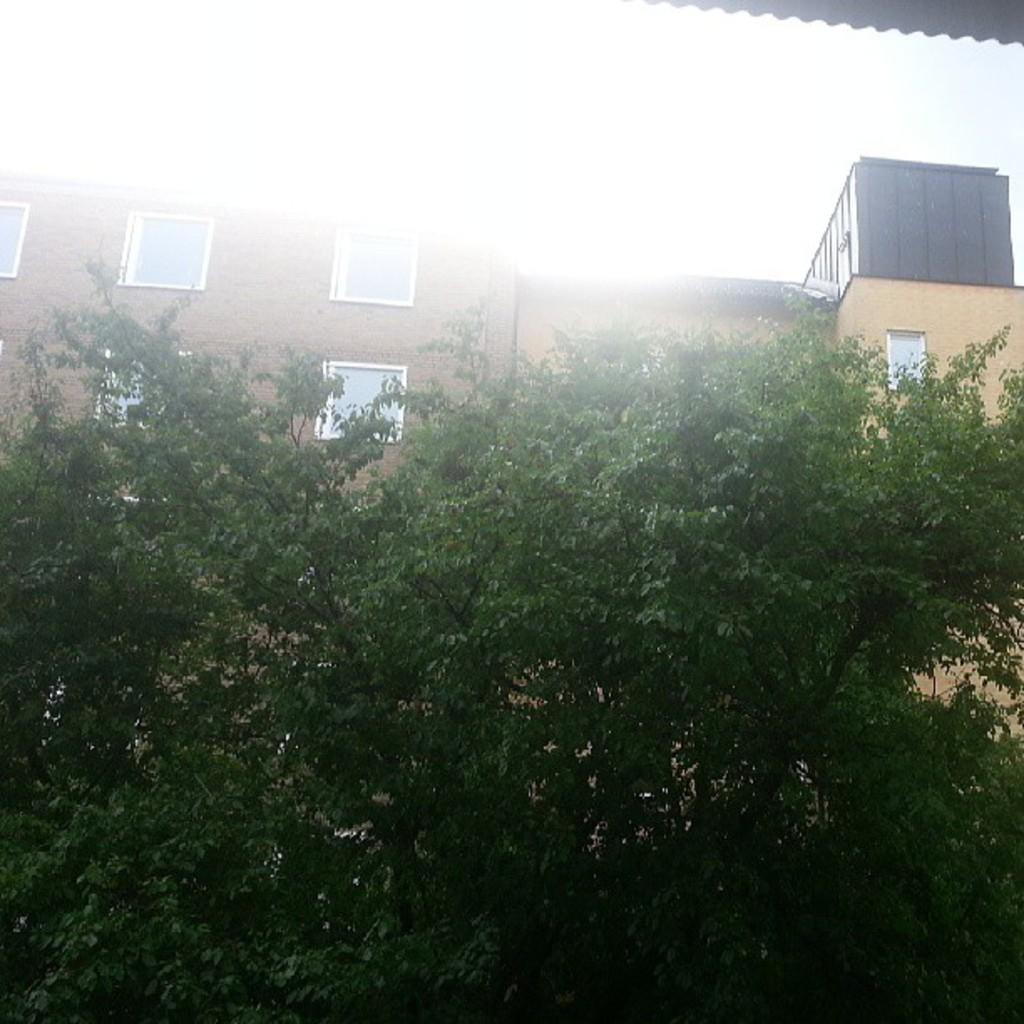What type of vegetation can be seen in the image? There are trees in the image. What type of building is visible in the image? There is a building with glass windows in the image. What type of reward is being given to the person in the image? There is no person present in the image, and therefore no reward can be observed. What sound can be heard in the image due to the presence of thunder? There is no sound or thunder present in the image; it only contains visual elements. 